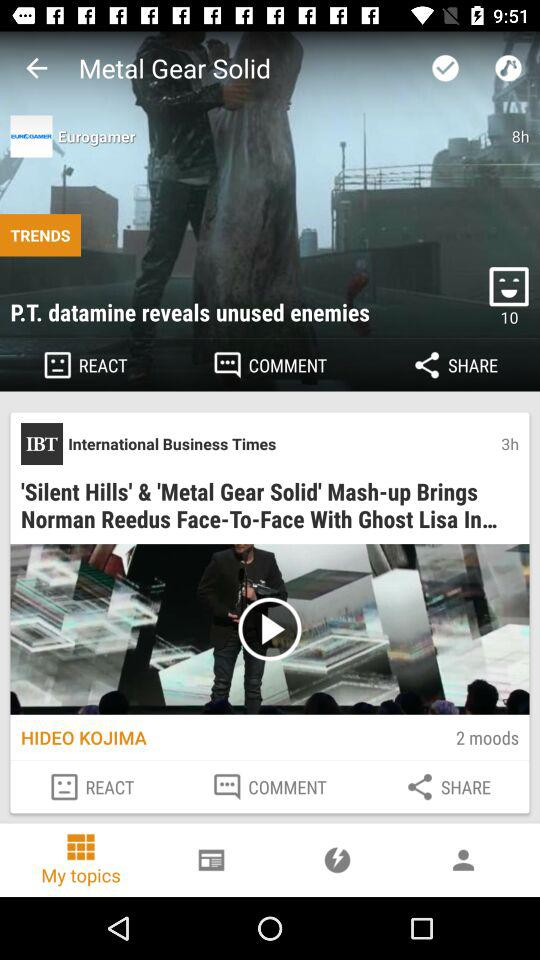How many hours ago was the news "P.T. datamine reveals unused enemies" posted? The news was posted 8 hours ago. 